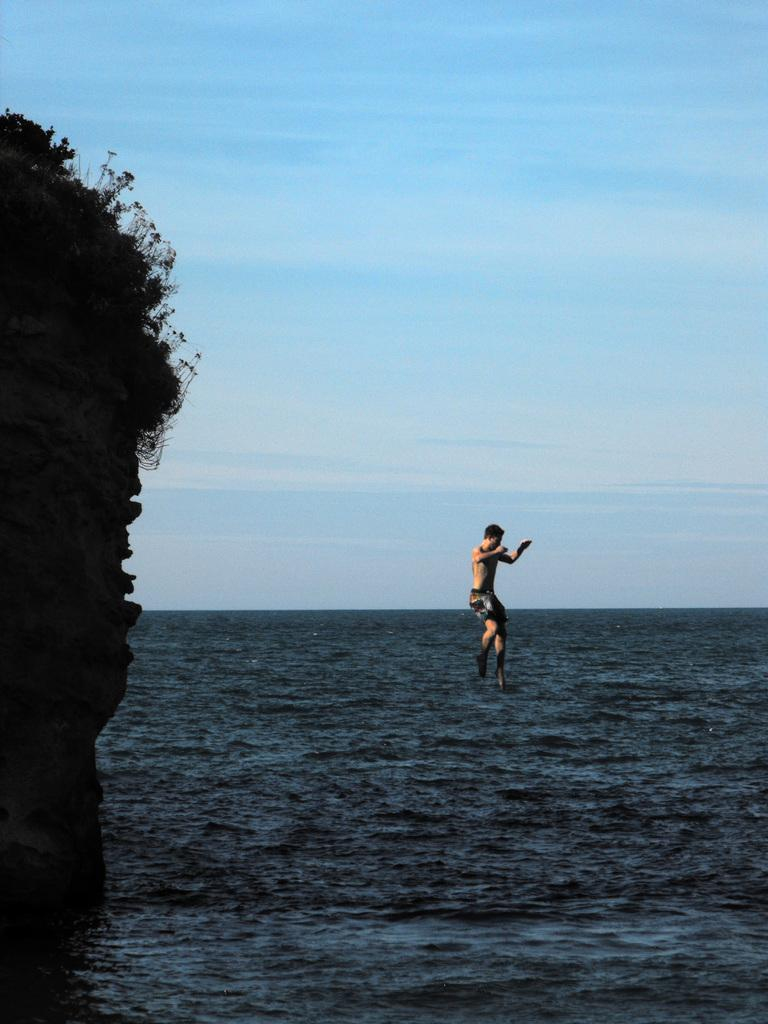What is the main subject of the image? There is a man in the air in the image. What natural feature can be seen in the image? The image contains the sea. What is visible in the background of the image? The sky is visible in the background of the image. What type of vegetation is present in the image? There are plants present in the image. What type of toy can be seen floating in the sea in the image? There is no toy present in the image; it only features a man in the air and plants. What type of beef is being cooked on the plants in the image? There is no beef or cooking activity present in the image; it only features a man in the air and plants. 